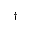Convert formula to latex. <formula><loc_0><loc_0><loc_500><loc_500>^ { \dag }</formula> 